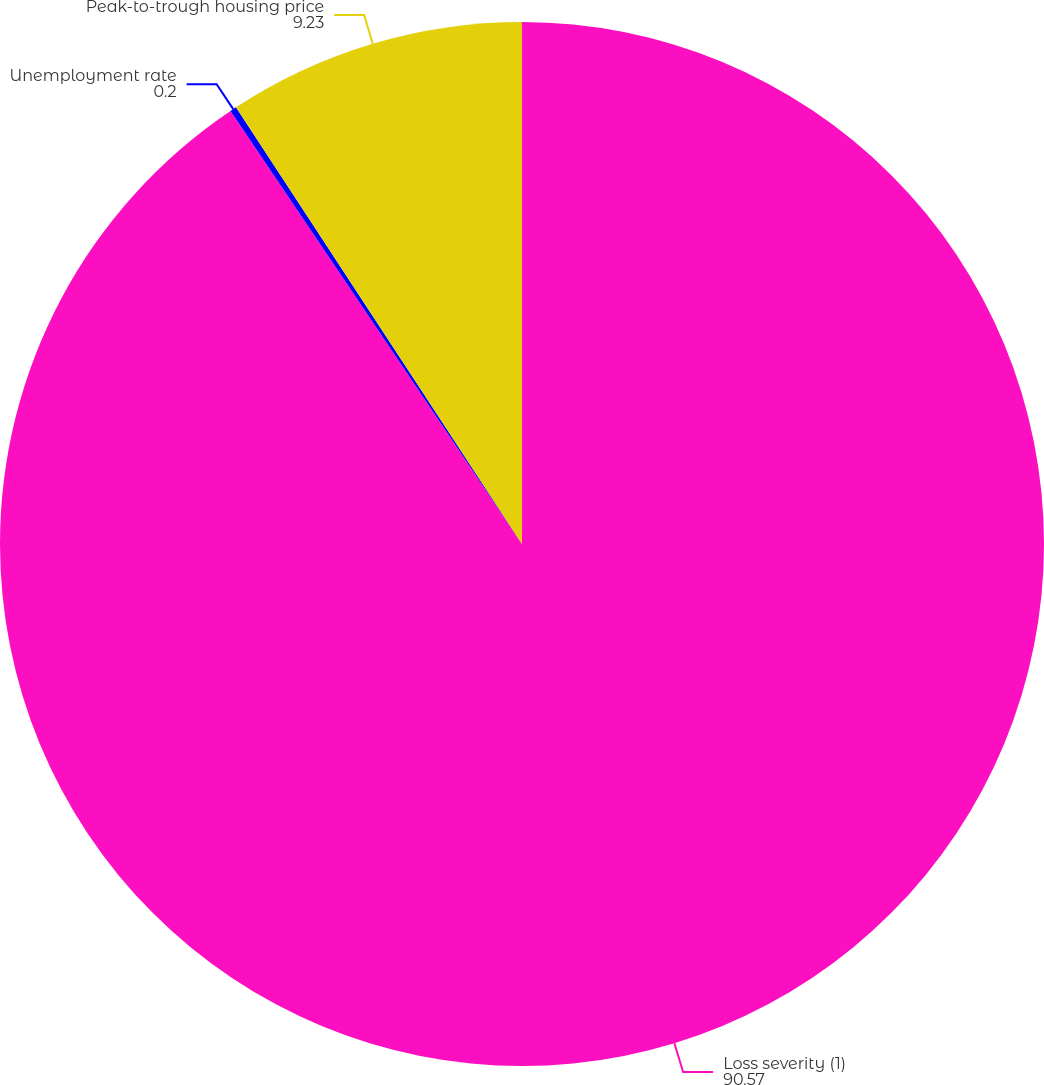<chart> <loc_0><loc_0><loc_500><loc_500><pie_chart><fcel>Loss severity (1)<fcel>Unemployment rate<fcel>Peak-to-trough housing price<nl><fcel>90.57%<fcel>0.2%<fcel>9.23%<nl></chart> 